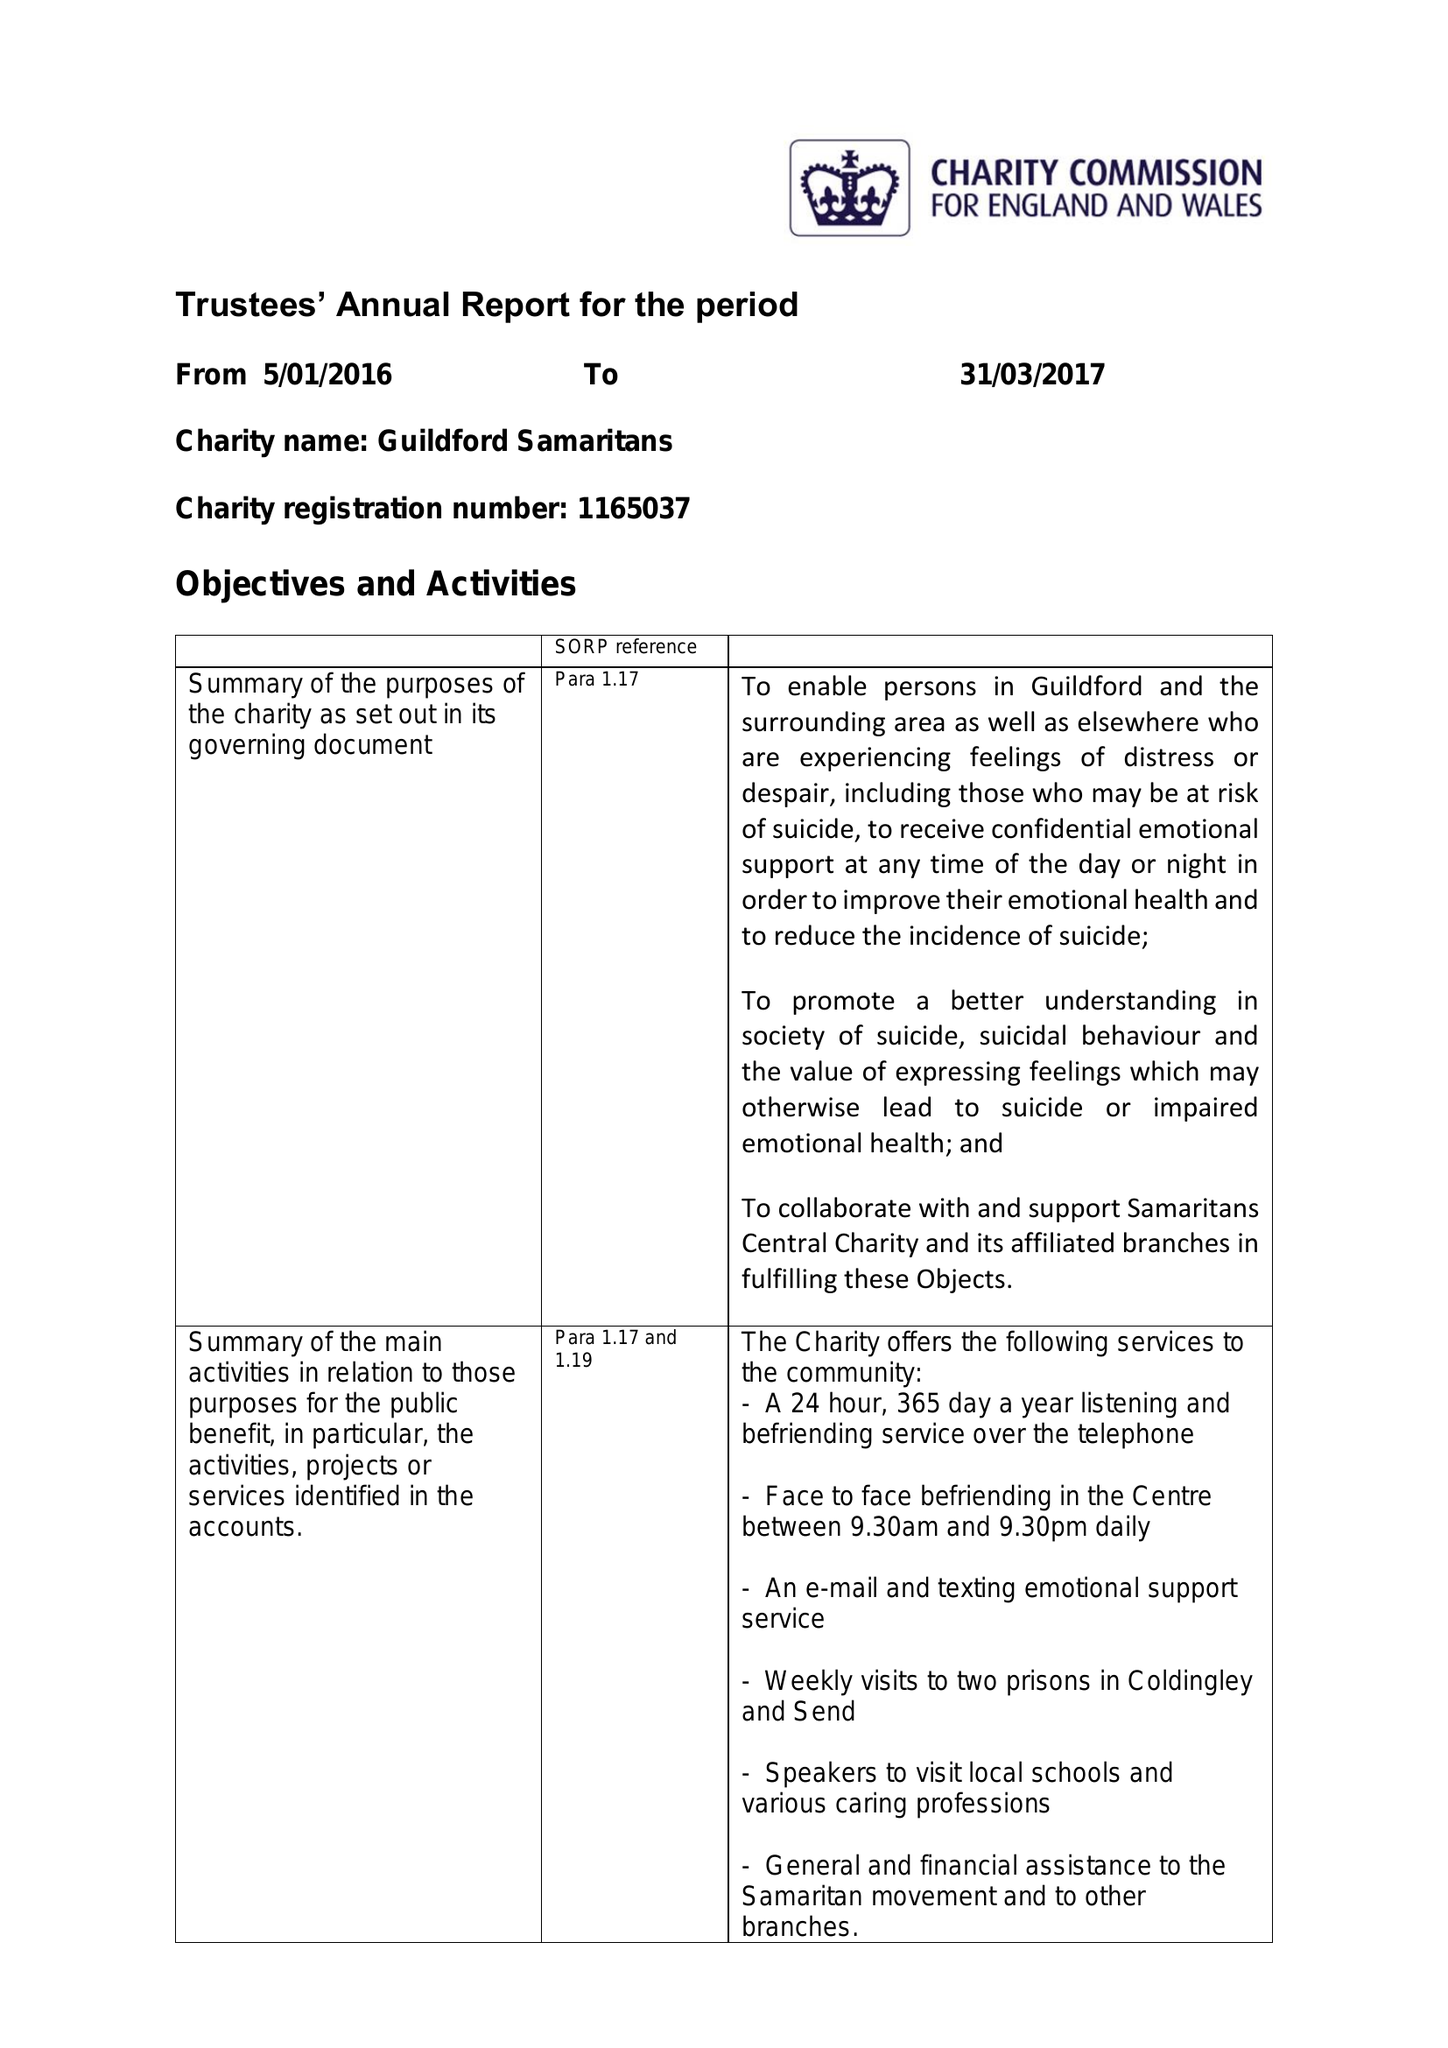What is the value for the income_annually_in_british_pounds?
Answer the question using a single word or phrase. 110582.00 